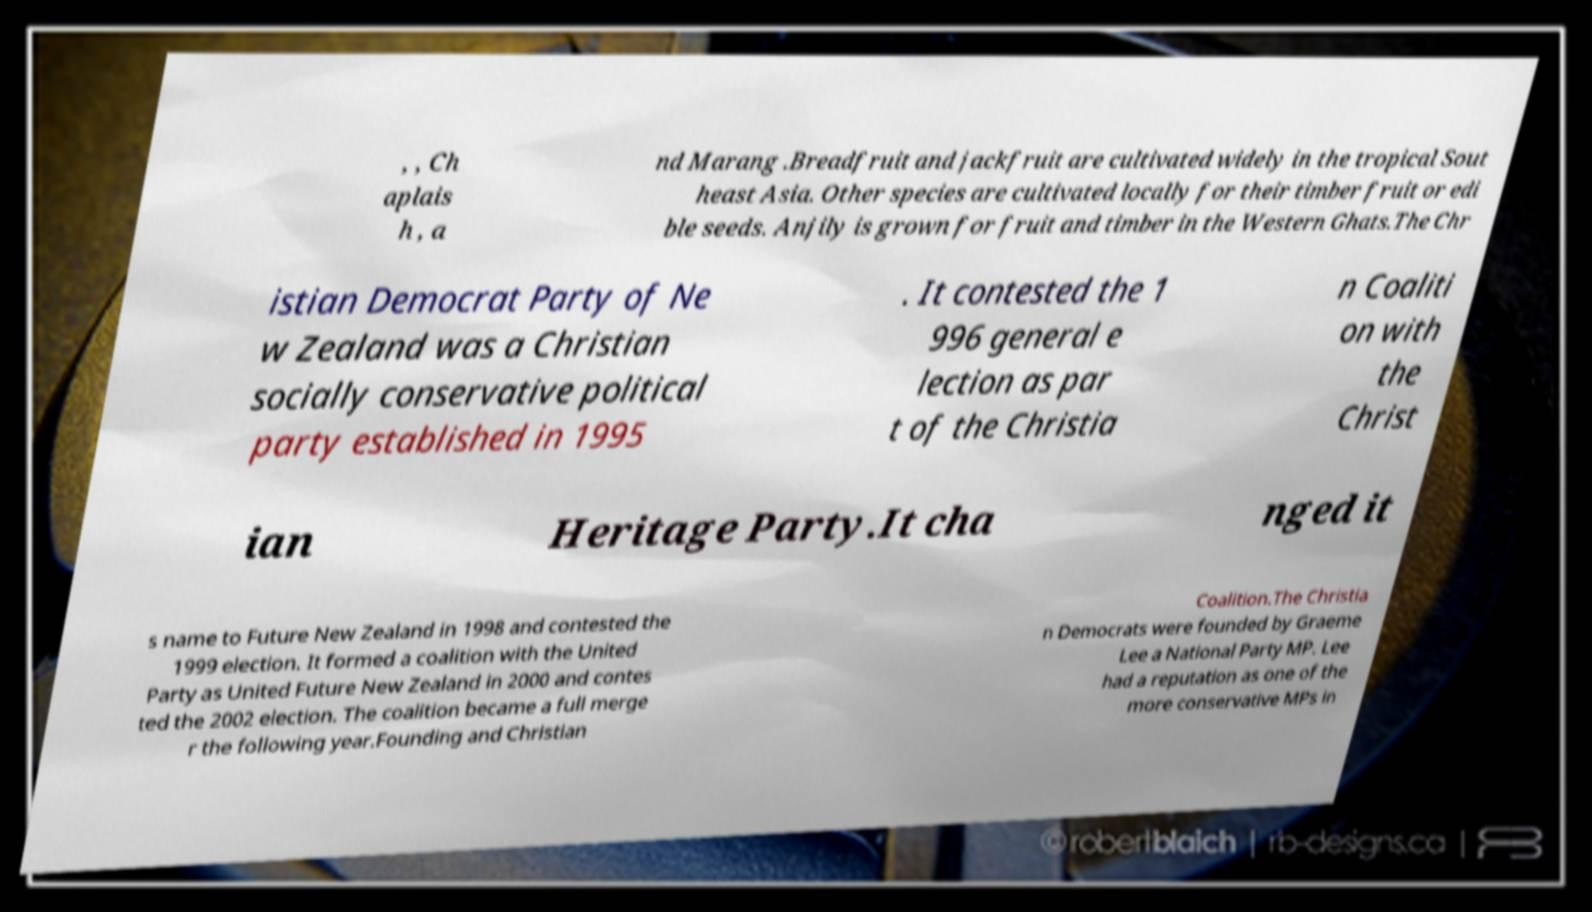I need the written content from this picture converted into text. Can you do that? , , Ch aplais h , a nd Marang .Breadfruit and jackfruit are cultivated widely in the tropical Sout heast Asia. Other species are cultivated locally for their timber fruit or edi ble seeds. Anjily is grown for fruit and timber in the Western Ghats.The Chr istian Democrat Party of Ne w Zealand was a Christian socially conservative political party established in 1995 . It contested the 1 996 general e lection as par t of the Christia n Coaliti on with the Christ ian Heritage Party.It cha nged it s name to Future New Zealand in 1998 and contested the 1999 election. It formed a coalition with the United Party as United Future New Zealand in 2000 and contes ted the 2002 election. The coalition became a full merge r the following year.Founding and Christian Coalition.The Christia n Democrats were founded by Graeme Lee a National Party MP. Lee had a reputation as one of the more conservative MPs in 